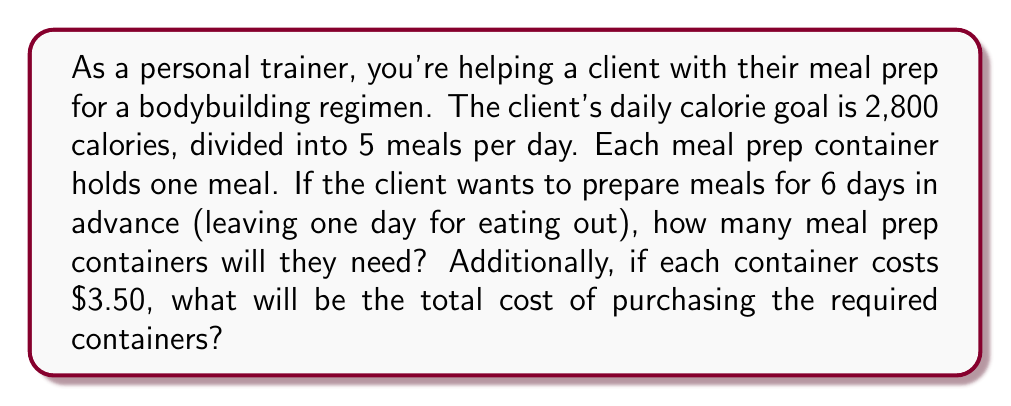What is the answer to this math problem? Let's break this problem down step-by-step:

1. Calculate the number of meals per week:
   - Daily meals = 5
   - Days of meal prep = 6
   - Total meals = $5 \times 6 = 30$ meals

2. Determine the number of containers needed:
   - Since each container holds one meal, the number of containers needed is equal to the total number of meals.
   - Number of containers = 30

3. Calculate the total cost of containers:
   - Cost per container = $3.50
   - Total cost = Number of containers $\times$ Cost per container
   - Total cost = $30 \times $3.50 = $105

Therefore, the client will need 30 meal prep containers, which will cost a total of $105.
Answer: The client will need 30 meal prep containers, costing a total of $105. 